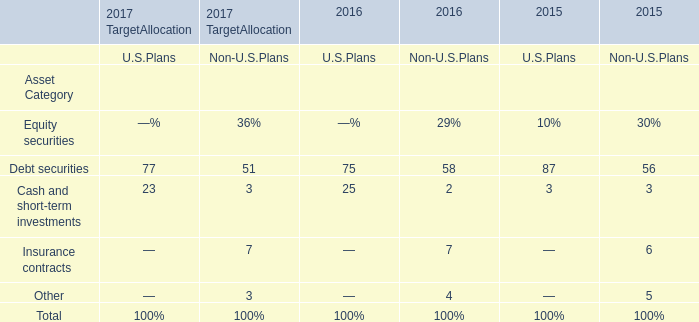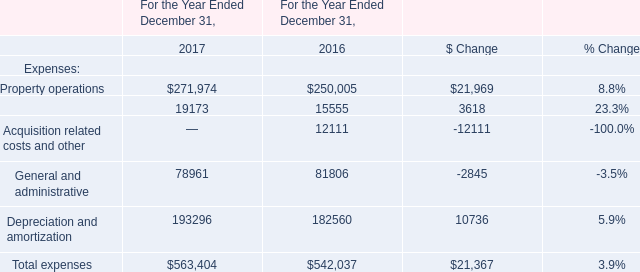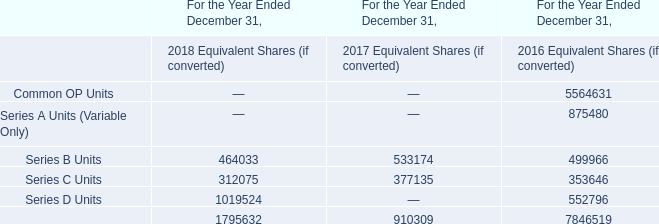What was the average value of Property operations, Tenant reinsurance, General and administrative in 2017? 
Computations: (((271974 + 19173) + 78961) / 3)
Answer: 123369.33333. 